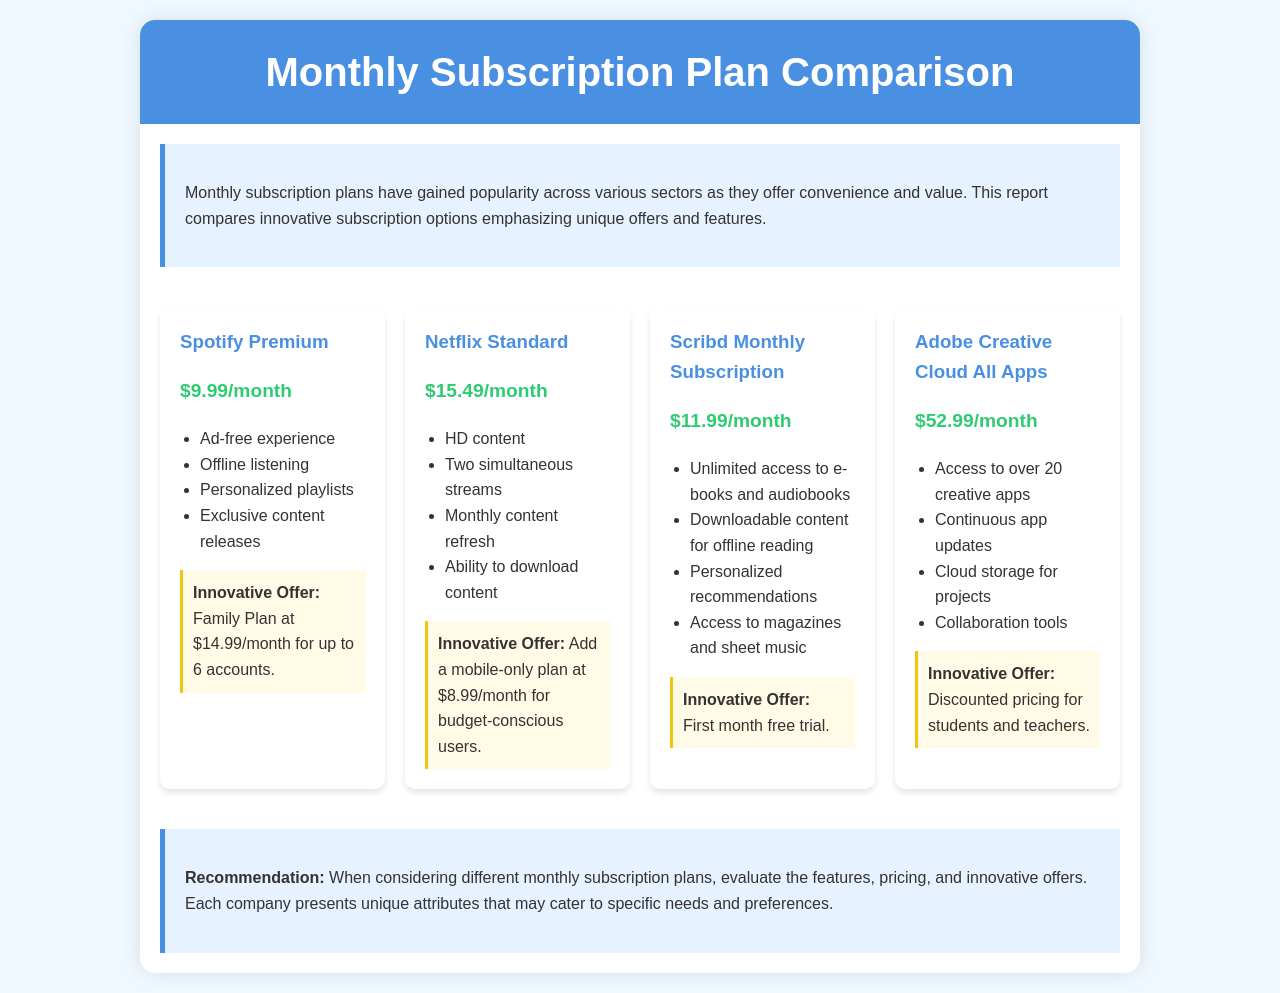What is the price of Spotify Premium? The price of Spotify Premium is listed in the document as $9.99/month.
Answer: $9.99/month How many simultaneous streams does Netflix Standard allow? The document states that Netflix Standard allows two simultaneous streams.
Answer: Two What is the innovative offer for Scribd Monthly Subscription? The document mentions that the innovative offer for Scribd is a first month free trial.
Answer: First month free trial What is the total monthly cost of the Family Plan for Spotify Premium? The Family Plan for Spotify Premium is priced at $14.99/month, which is specified in the innovative offer section.
Answer: $14.99/month Which subscription offers discounted pricing for students and teachers? According to the document, Adobe Creative Cloud All Apps offers discounted pricing for students and teachers.
Answer: Adobe Creative Cloud All Apps What features are unique to Adobe Creative Cloud? The document lists access to over 20 creative apps, continuous app updates, cloud storage for projects, and collaboration tools as features of Adobe Creative Cloud.
Answer: Over 20 creative apps, continuous updates, cloud storage, collaboration tools Which subscription includes offline listening? The document specifies that offline listening is a feature of Spotify Premium.
Answer: Spotify Premium What is the purpose of the introduction section in the document? The introduction explains the popularity and value of monthly subscription plans and sets the context for the comparison.
Answer: Context for the comparison How many accounts can use the Family Plan of Spotify Premium? The Family Plan allows up to 6 accounts as mentioned in the document.
Answer: Up to 6 accounts 